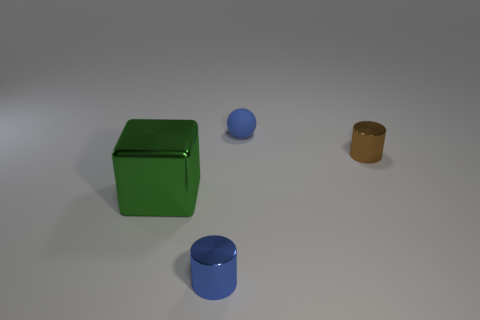Subtract all brown cylinders. How many cylinders are left? 1 Subtract 1 cylinders. How many cylinders are left? 1 Add 1 brown cylinders. How many brown cylinders exist? 2 Add 3 large metal blocks. How many objects exist? 7 Subtract 0 yellow blocks. How many objects are left? 4 Subtract all blocks. How many objects are left? 3 Subtract all gray cylinders. Subtract all red spheres. How many cylinders are left? 2 Subtract all red cylinders. How many green balls are left? 0 Subtract all small blue objects. Subtract all large purple metal balls. How many objects are left? 2 Add 3 tiny things. How many tiny things are left? 6 